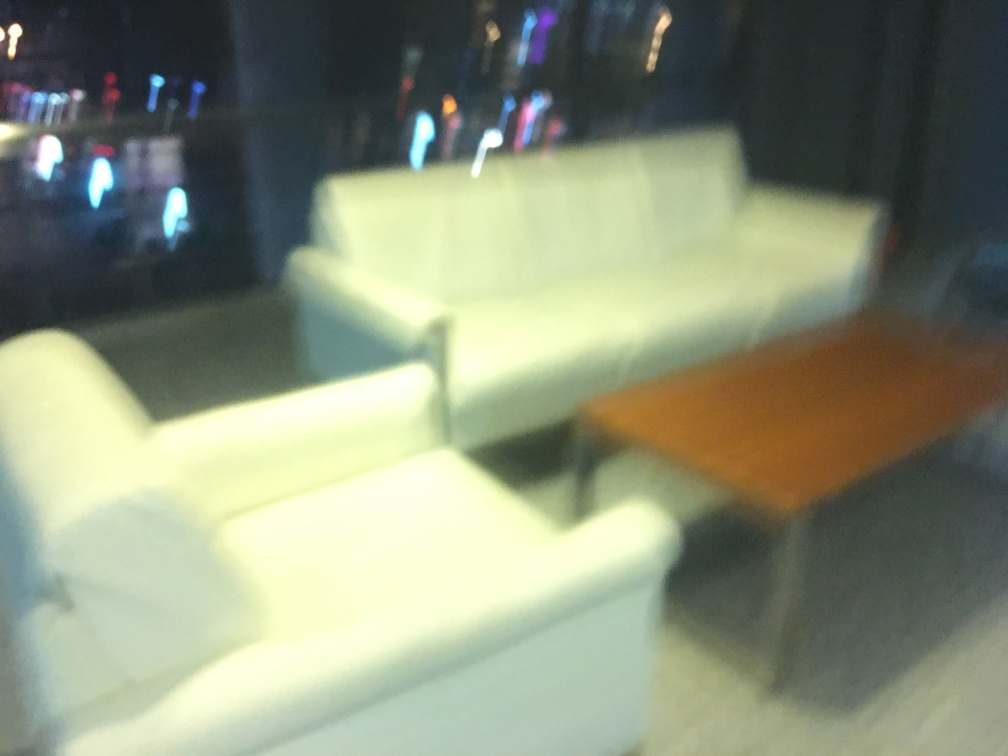Can you guess the time of day this photo was taken? Inferring from the blurriness and the artificial lights in the background, it seems as if this photo might have been taken in low-light conditions, possibly during the evening or at night. The lack of natural light coming through what appears to be a window supports this hypothesis. What could have caused the blurriness of the photo? The blurriness could result from several factors: the camera may have been moved during the exposure, the autofocus might have failed to lock onto a subject properly, or a manual focus setting might have been incorrectly set. Additionally, if taken in a dimly-lit area, the camera's longer exposure time to compensate for low light could have contributed to the blur if not stabilized. 